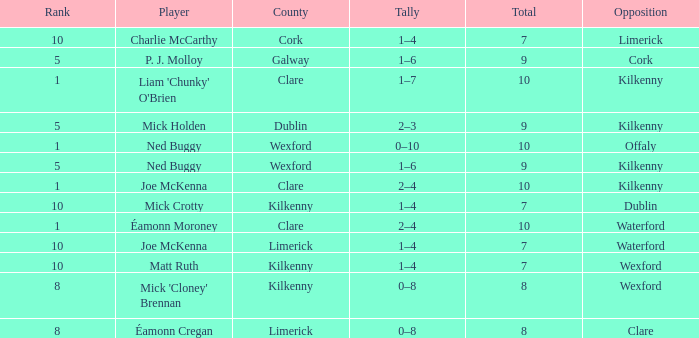Which Total has a County of kilkenny, and a Tally of 1–4, and a Rank larger than 10? None. 